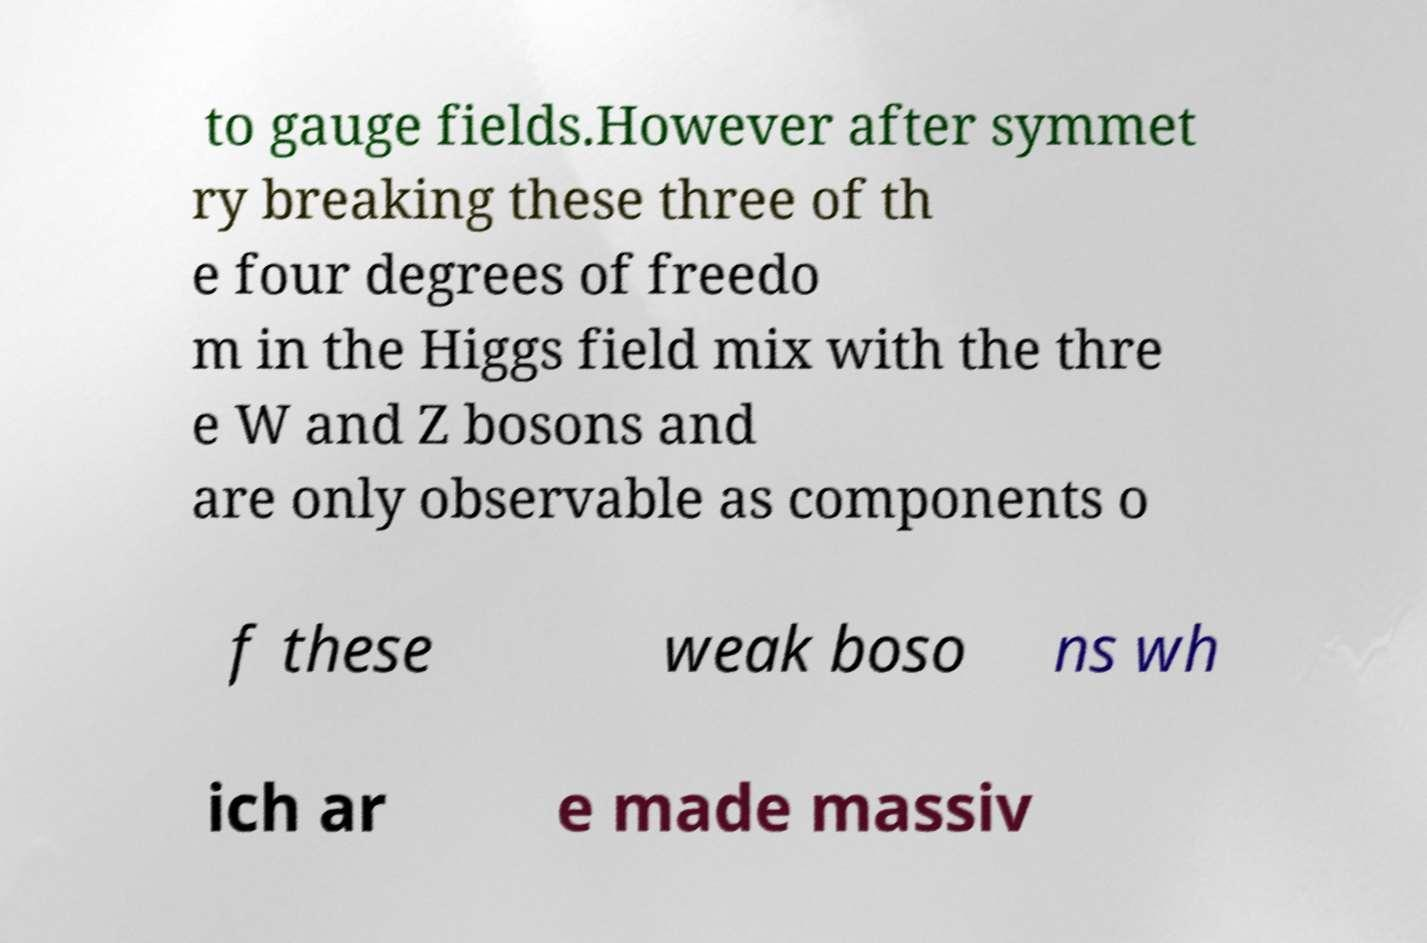Please read and relay the text visible in this image. What does it say? to gauge fields.However after symmet ry breaking these three of th e four degrees of freedo m in the Higgs field mix with the thre e W and Z bosons and are only observable as components o f these weak boso ns wh ich ar e made massiv 